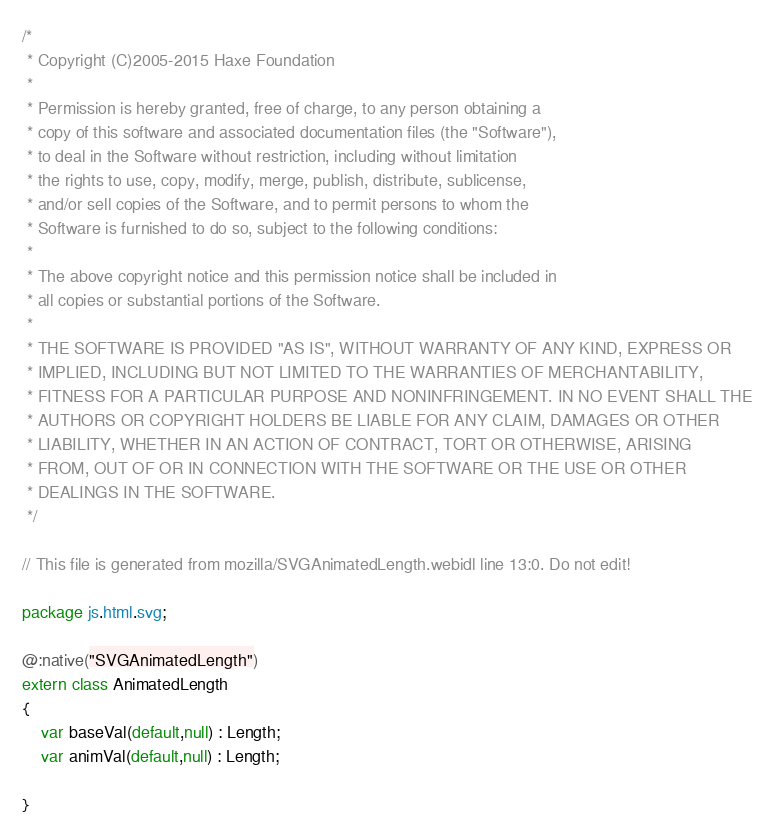Convert code to text. <code><loc_0><loc_0><loc_500><loc_500><_Haxe_>/*
 * Copyright (C)2005-2015 Haxe Foundation
 *
 * Permission is hereby granted, free of charge, to any person obtaining a
 * copy of this software and associated documentation files (the "Software"),
 * to deal in the Software without restriction, including without limitation
 * the rights to use, copy, modify, merge, publish, distribute, sublicense,
 * and/or sell copies of the Software, and to permit persons to whom the
 * Software is furnished to do so, subject to the following conditions:
 *
 * The above copyright notice and this permission notice shall be included in
 * all copies or substantial portions of the Software.
 *
 * THE SOFTWARE IS PROVIDED "AS IS", WITHOUT WARRANTY OF ANY KIND, EXPRESS OR
 * IMPLIED, INCLUDING BUT NOT LIMITED TO THE WARRANTIES OF MERCHANTABILITY,
 * FITNESS FOR A PARTICULAR PURPOSE AND NONINFRINGEMENT. IN NO EVENT SHALL THE
 * AUTHORS OR COPYRIGHT HOLDERS BE LIABLE FOR ANY CLAIM, DAMAGES OR OTHER
 * LIABILITY, WHETHER IN AN ACTION OF CONTRACT, TORT OR OTHERWISE, ARISING
 * FROM, OUT OF OR IN CONNECTION WITH THE SOFTWARE OR THE USE OR OTHER
 * DEALINGS IN THE SOFTWARE.
 */

// This file is generated from mozilla/SVGAnimatedLength.webidl line 13:0. Do not edit!

package js.html.svg;

@:native("SVGAnimatedLength")
extern class AnimatedLength
{
	var baseVal(default,null) : Length;
	var animVal(default,null) : Length;
	
}</code> 